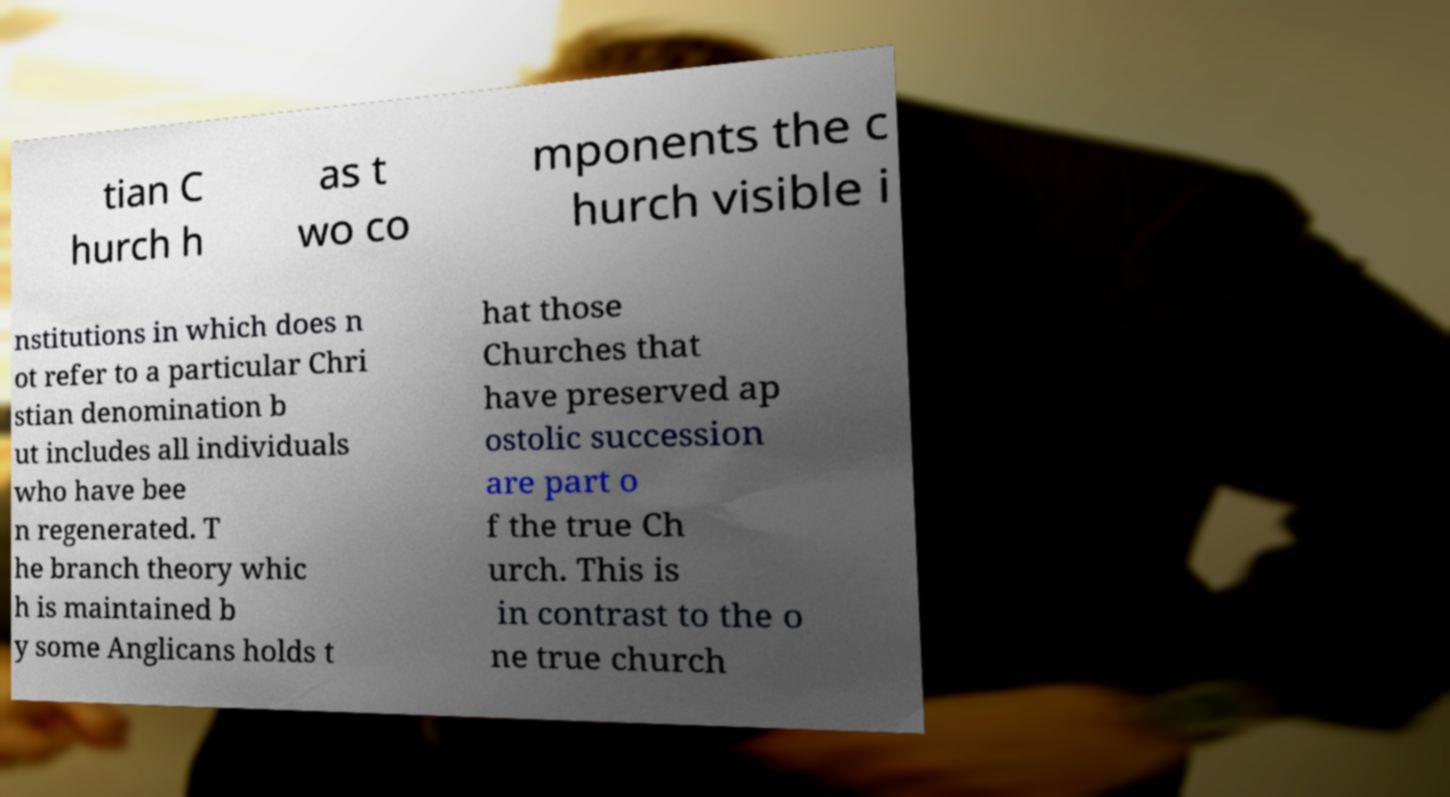Please identify and transcribe the text found in this image. tian C hurch h as t wo co mponents the c hurch visible i nstitutions in which does n ot refer to a particular Chri stian denomination b ut includes all individuals who have bee n regenerated. T he branch theory whic h is maintained b y some Anglicans holds t hat those Churches that have preserved ap ostolic succession are part o f the true Ch urch. This is in contrast to the o ne true church 